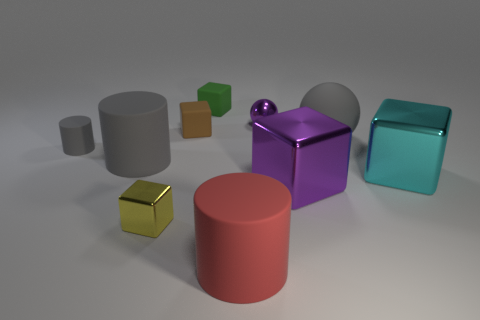Subtract all red cylinders. How many cylinders are left? 2 Subtract all small cubes. How many cubes are left? 2 Subtract 1 purple balls. How many objects are left? 9 Subtract all cylinders. How many objects are left? 7 Subtract 1 spheres. How many spheres are left? 1 Subtract all purple cylinders. Subtract all yellow balls. How many cylinders are left? 3 Subtract all purple blocks. How many yellow cylinders are left? 0 Subtract all purple balls. Subtract all tiny blue rubber balls. How many objects are left? 9 Add 3 big gray matte cylinders. How many big gray matte cylinders are left? 4 Add 6 big gray cylinders. How many big gray cylinders exist? 7 